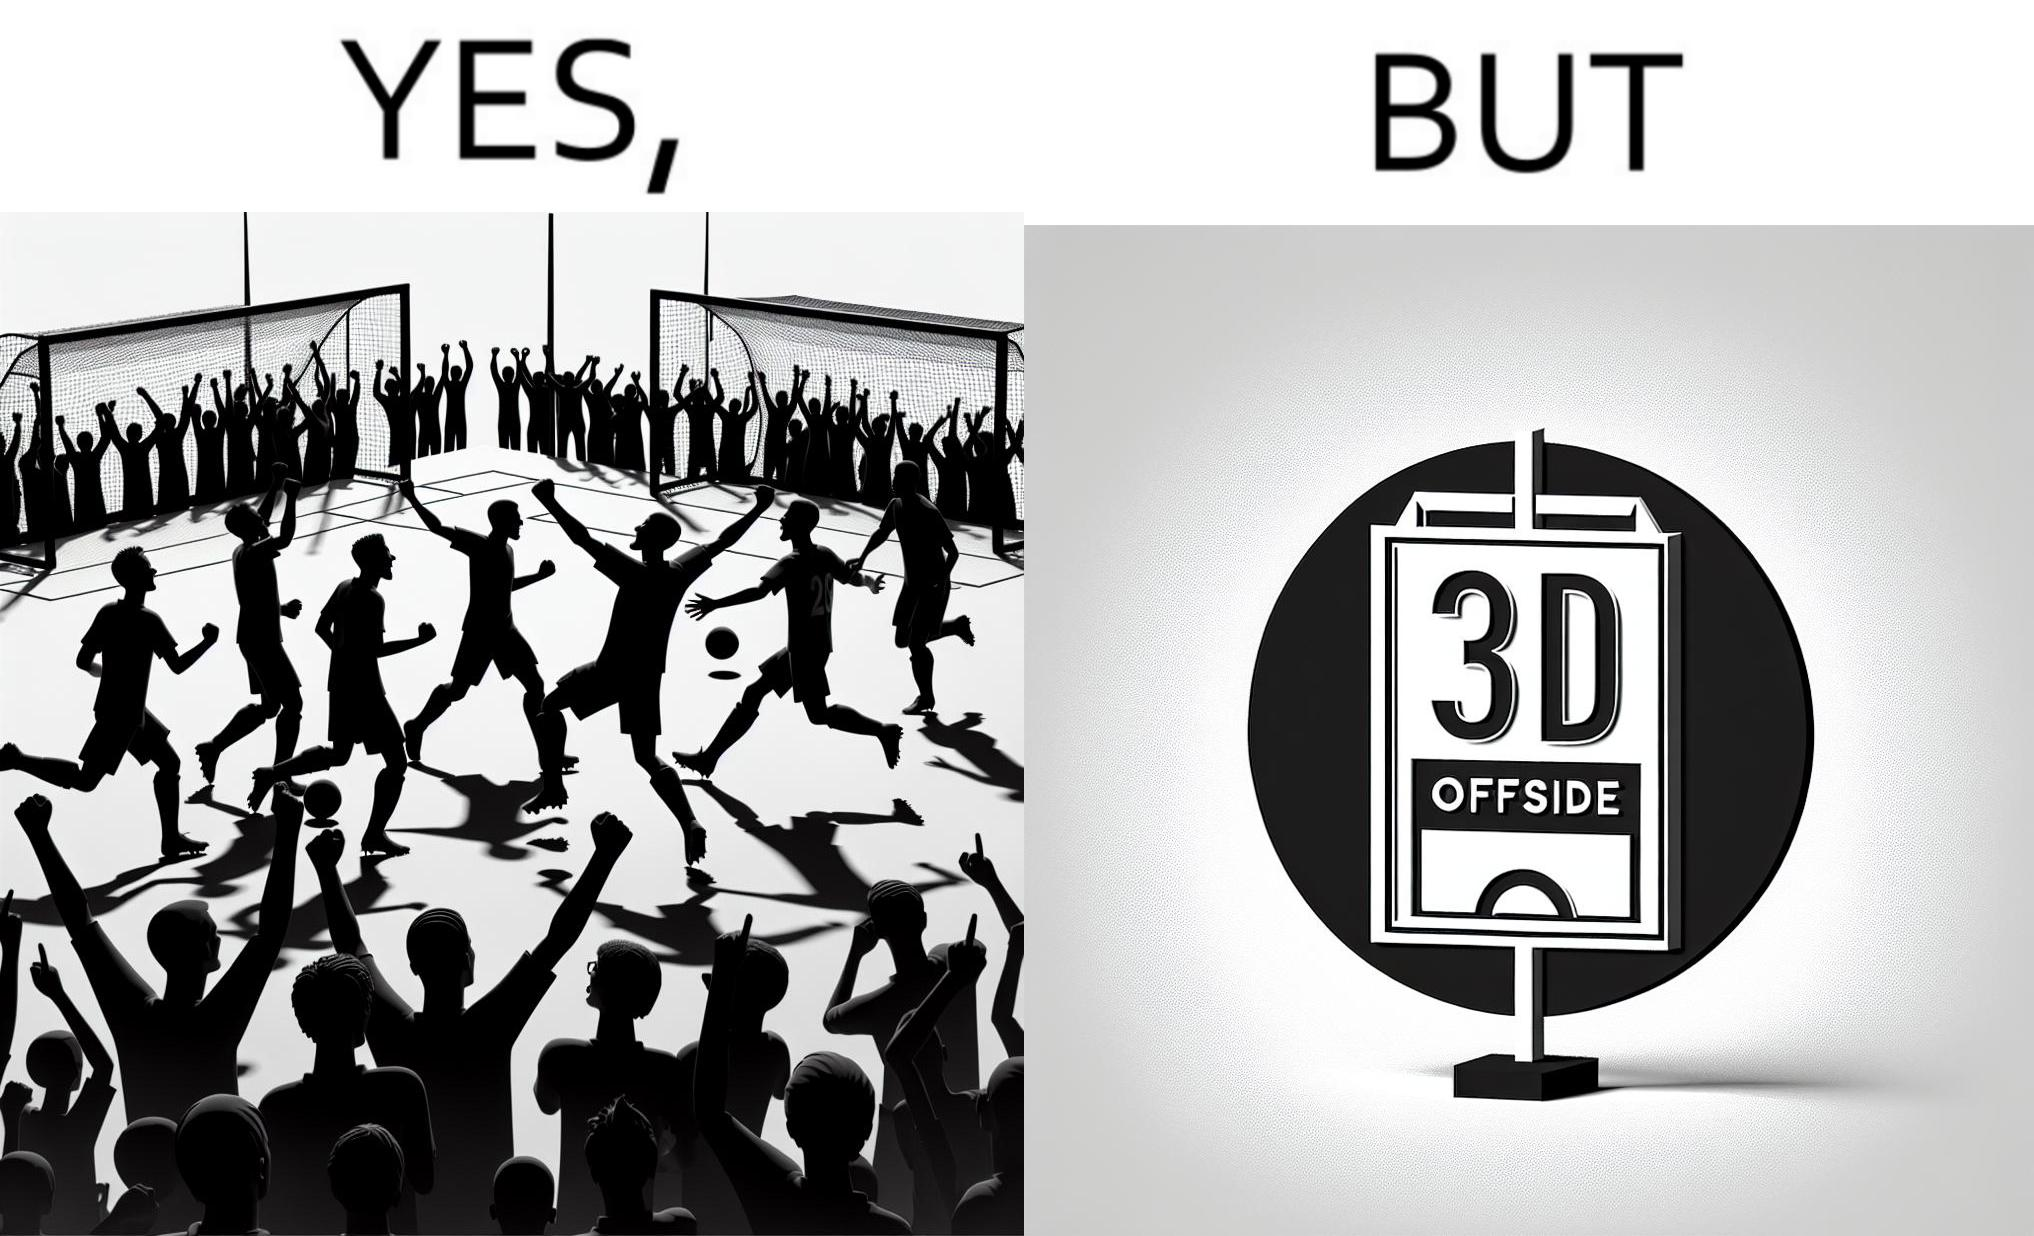Describe the content of this image. The image is ironical, as the team is celebrating as they think that they have scored a goal, but the sign on the screen says that it is an offside, and not a goal. This is a very common scenario in football matches. 